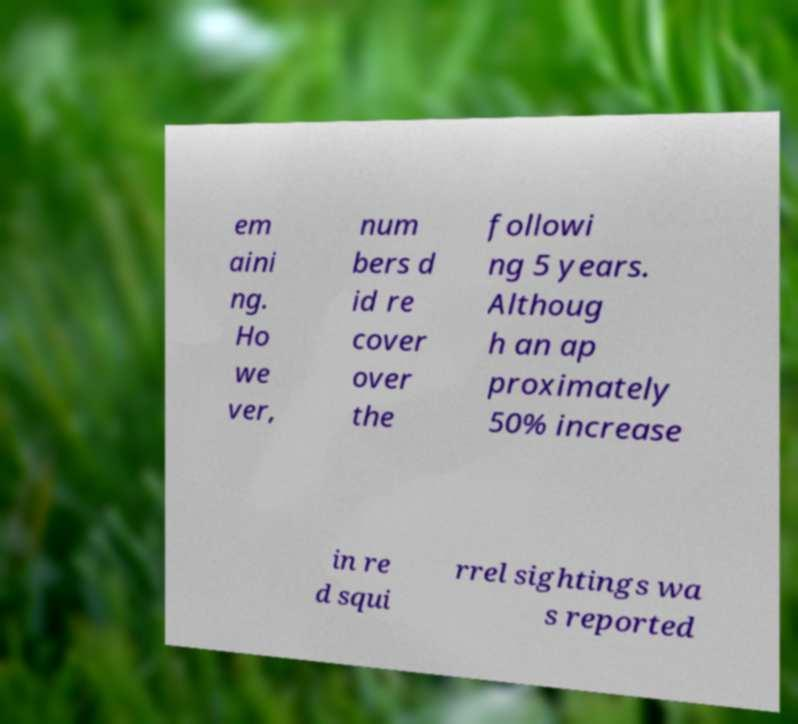What messages or text are displayed in this image? I need them in a readable, typed format. em aini ng. Ho we ver, num bers d id re cover over the followi ng 5 years. Althoug h an ap proximately 50% increase in re d squi rrel sightings wa s reported 